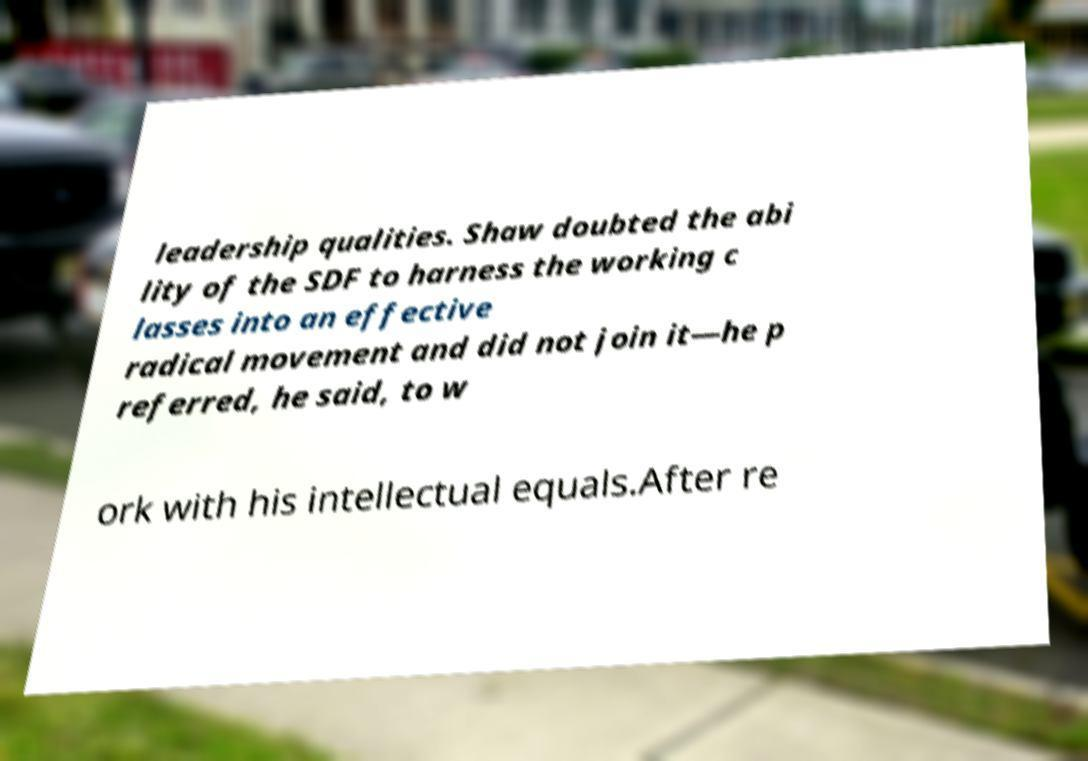What messages or text are displayed in this image? I need them in a readable, typed format. leadership qualities. Shaw doubted the abi lity of the SDF to harness the working c lasses into an effective radical movement and did not join it—he p referred, he said, to w ork with his intellectual equals.After re 